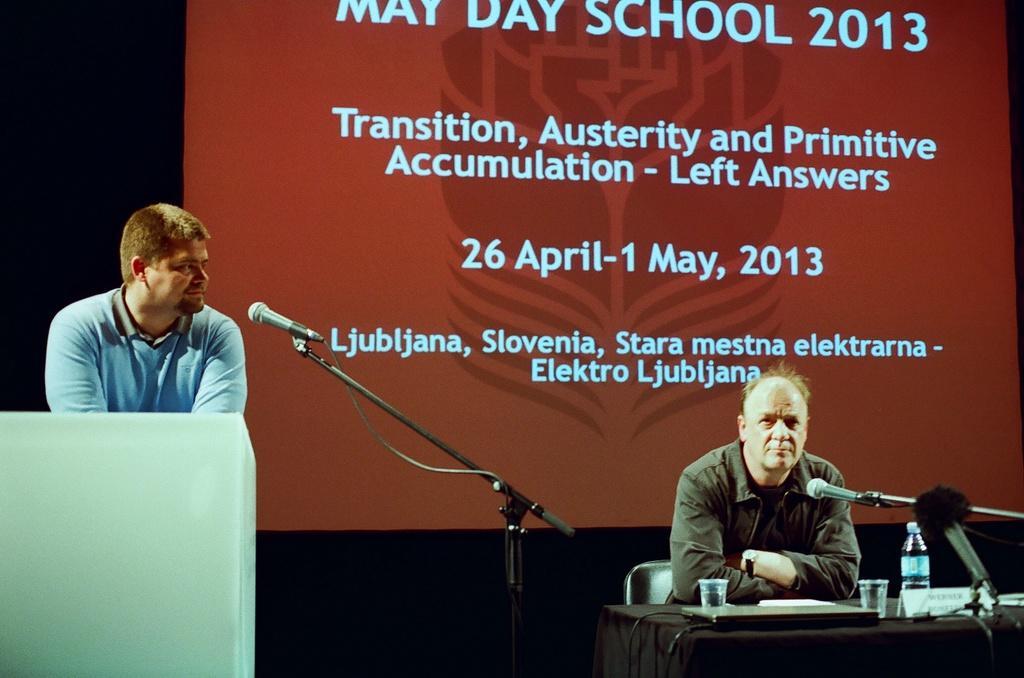Could you give a brief overview of what you see in this image? In this picture we can see a man is sitting on a chair and in front of the man there is a table and on there is a laptop, glasses, name board, bottle and a microphone with the strand. On the left side of the people there is another microphone with stand and another person is standing behind the podium. Behind the people there is a screen. 